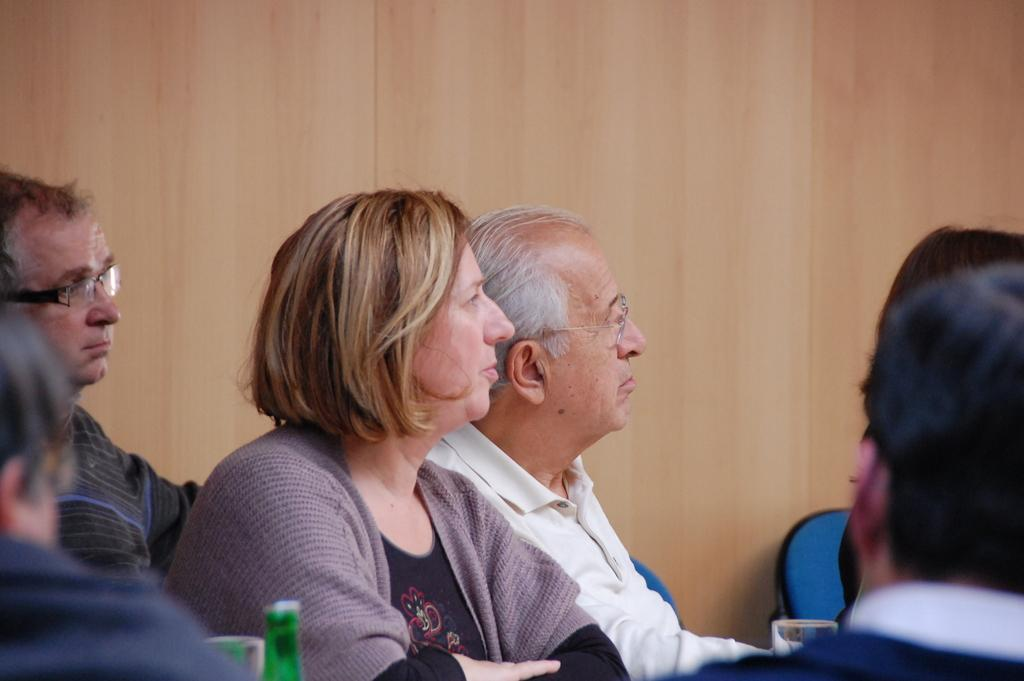What are the people in the image doing? There are persons sitting in the image. What objects can be seen at the bottom of the image? There are glasses and a wine bottle at the bottom of the image. What type of furniture is visible in the background of the image? There are chairs in the background of the image. How are the chairs positioned in relation to the wall? The chairs are against a wall. What type of hen can be seen flying in the image? There is no hen present in the image. What type of pancake is being served on the air in the image? There is no pancake or air present in the image. 